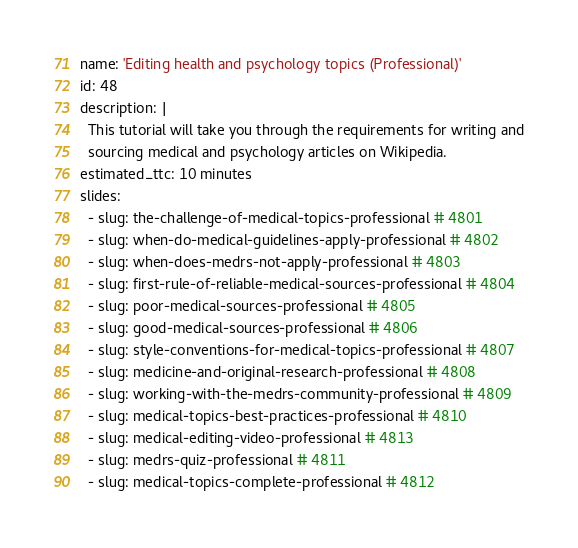<code> <loc_0><loc_0><loc_500><loc_500><_YAML_>name: 'Editing health and psychology topics (Professional)'
id: 48
description: |
  This tutorial will take you through the requirements for writing and
  sourcing medical and psychology articles on Wikipedia.
estimated_ttc: 10 minutes
slides:
  - slug: the-challenge-of-medical-topics-professional # 4801
  - slug: when-do-medical-guidelines-apply-professional # 4802
  - slug: when-does-medrs-not-apply-professional # 4803
  - slug: first-rule-of-reliable-medical-sources-professional # 4804
  - slug: poor-medical-sources-professional # 4805
  - slug: good-medical-sources-professional # 4806
  - slug: style-conventions-for-medical-topics-professional # 4807
  - slug: medicine-and-original-research-professional # 4808
  - slug: working-with-the-medrs-community-professional # 4809
  - slug: medical-topics-best-practices-professional # 4810
  - slug: medical-editing-video-professional # 4813
  - slug: medrs-quiz-professional # 4811
  - slug: medical-topics-complete-professional # 4812
</code> 